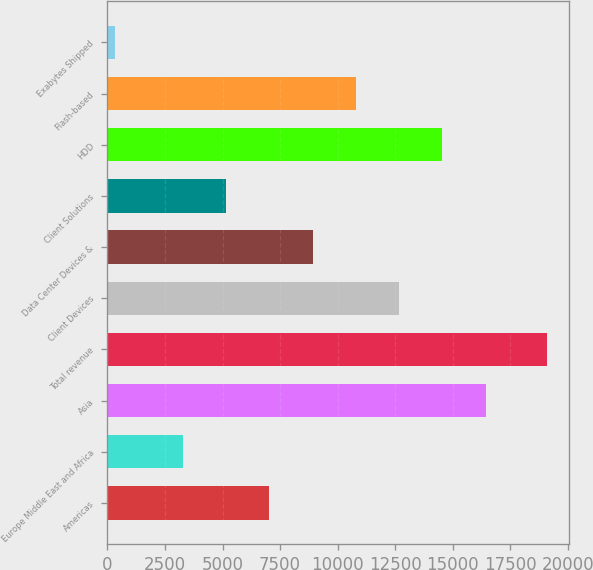<chart> <loc_0><loc_0><loc_500><loc_500><bar_chart><fcel>Americas<fcel>Europe Middle East and Africa<fcel>Asia<fcel>Total revenue<fcel>Client Devices<fcel>Data Center Devices &<fcel>Client Solutions<fcel>HDD<fcel>Flash-based<fcel>Exabytes Shipped<nl><fcel>7032<fcel>3276<fcel>16422<fcel>19093<fcel>12666<fcel>8910<fcel>5154<fcel>14544<fcel>10788<fcel>313<nl></chart> 